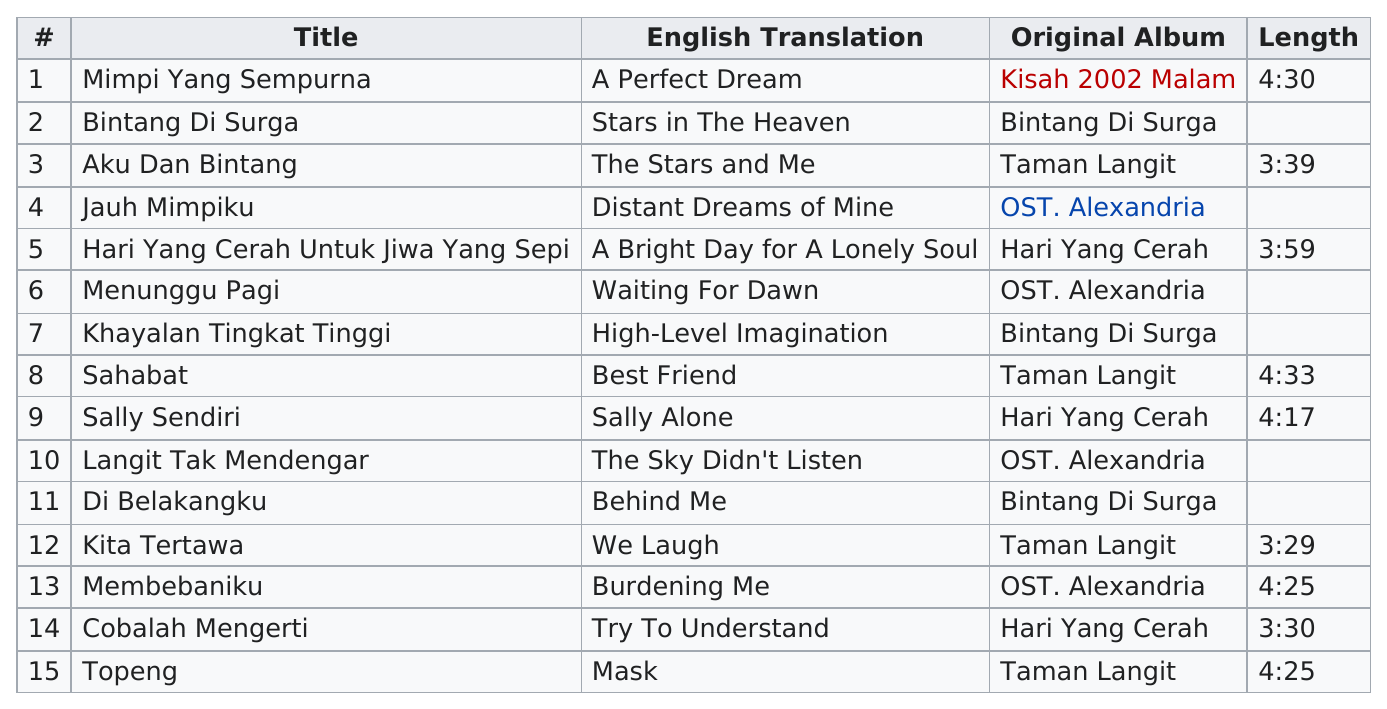Highlight a few significant elements in this photo. There are 3 songs on the "Bintang di Surga" album that were also featured on another album. Another album with the same duration as "TOPeng" is "Membebaniku..". The eleventh track is "Di belakangku," and the next one is "Kita Tertawa." Out of the 6 albums reviewed, 6 did not have a specific time length listed. The album "Sahabat Allah" was at least 4 minutes and 32 seconds long. 